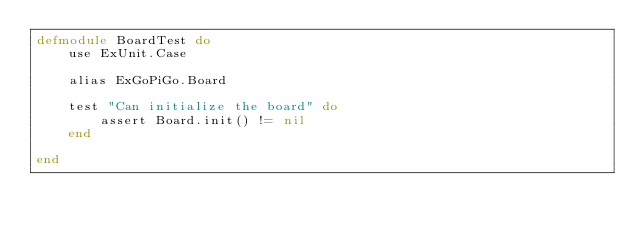Convert code to text. <code><loc_0><loc_0><loc_500><loc_500><_Elixir_>defmodule BoardTest do
	use ExUnit.Case

	alias ExGoPiGo.Board

	test "Can initialize the board" do
		assert Board.init() != nil
	end

end</code> 